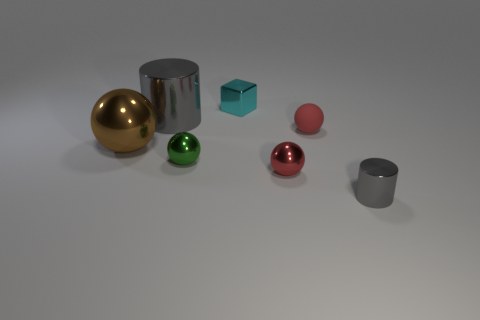Are there any objects in the image that reflect light differently, and what does that tell us about their surfaces? Indeed, each object reflects light uniquely. The gold and red spheres, as well as the green one, have high-gloss finishes that show sharp reflections, implying they have very smooth surfaces. The gray cylinder and the square turquoise object have more subdued, matte finishes, indicating less smooth surfaces. 